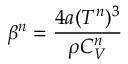<formula> <loc_0><loc_0><loc_500><loc_500>\beta ^ { n } = \frac { 4 a ( T ^ { n } ) ^ { 3 } } { \rho C _ { V } ^ { n } }</formula> 